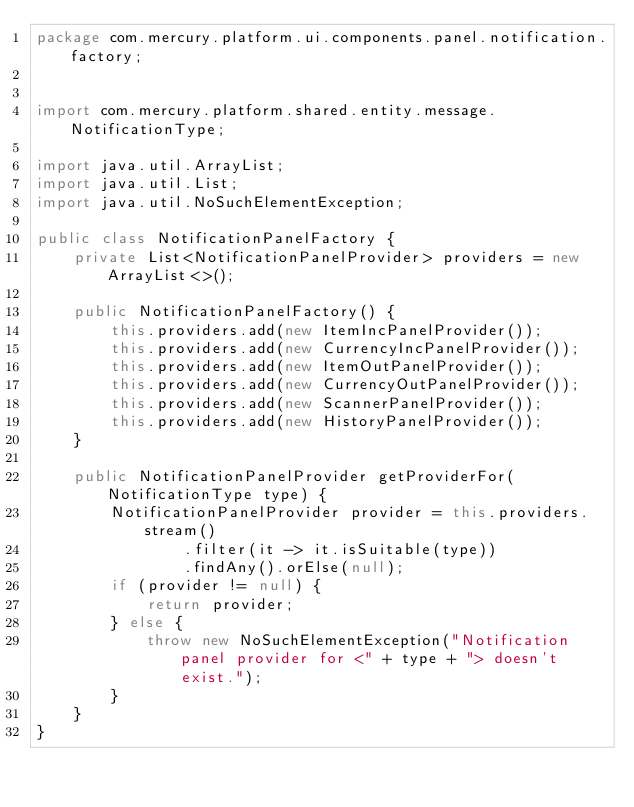<code> <loc_0><loc_0><loc_500><loc_500><_Java_>package com.mercury.platform.ui.components.panel.notification.factory;


import com.mercury.platform.shared.entity.message.NotificationType;

import java.util.ArrayList;
import java.util.List;
import java.util.NoSuchElementException;

public class NotificationPanelFactory {
    private List<NotificationPanelProvider> providers = new ArrayList<>();

    public NotificationPanelFactory() {
        this.providers.add(new ItemIncPanelProvider());
        this.providers.add(new CurrencyIncPanelProvider());
        this.providers.add(new ItemOutPanelProvider());
        this.providers.add(new CurrencyOutPanelProvider());
        this.providers.add(new ScannerPanelProvider());
        this.providers.add(new HistoryPanelProvider());
    }

    public NotificationPanelProvider getProviderFor(NotificationType type) {
        NotificationPanelProvider provider = this.providers.stream()
                .filter(it -> it.isSuitable(type))
                .findAny().orElse(null);
        if (provider != null) {
            return provider;
        } else {
            throw new NoSuchElementException("Notification panel provider for <" + type + "> doesn't exist.");
        }
    }
}
</code> 